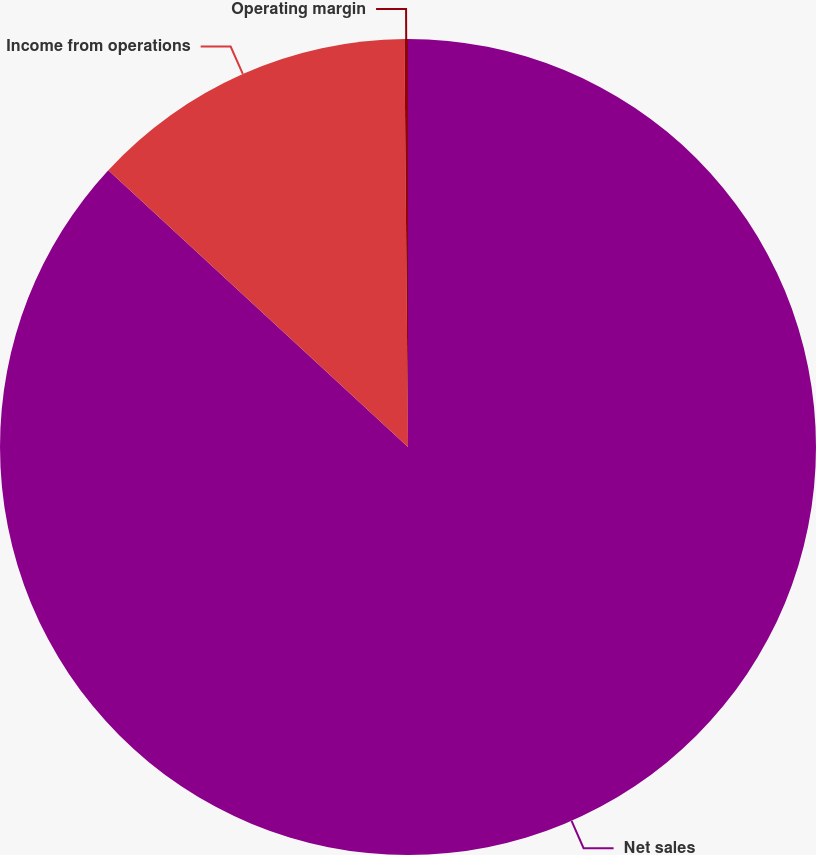<chart> <loc_0><loc_0><loc_500><loc_500><pie_chart><fcel>Net sales<fcel>Income from operations<fcel>Operating margin<nl><fcel>86.87%<fcel>12.99%<fcel>0.14%<nl></chart> 